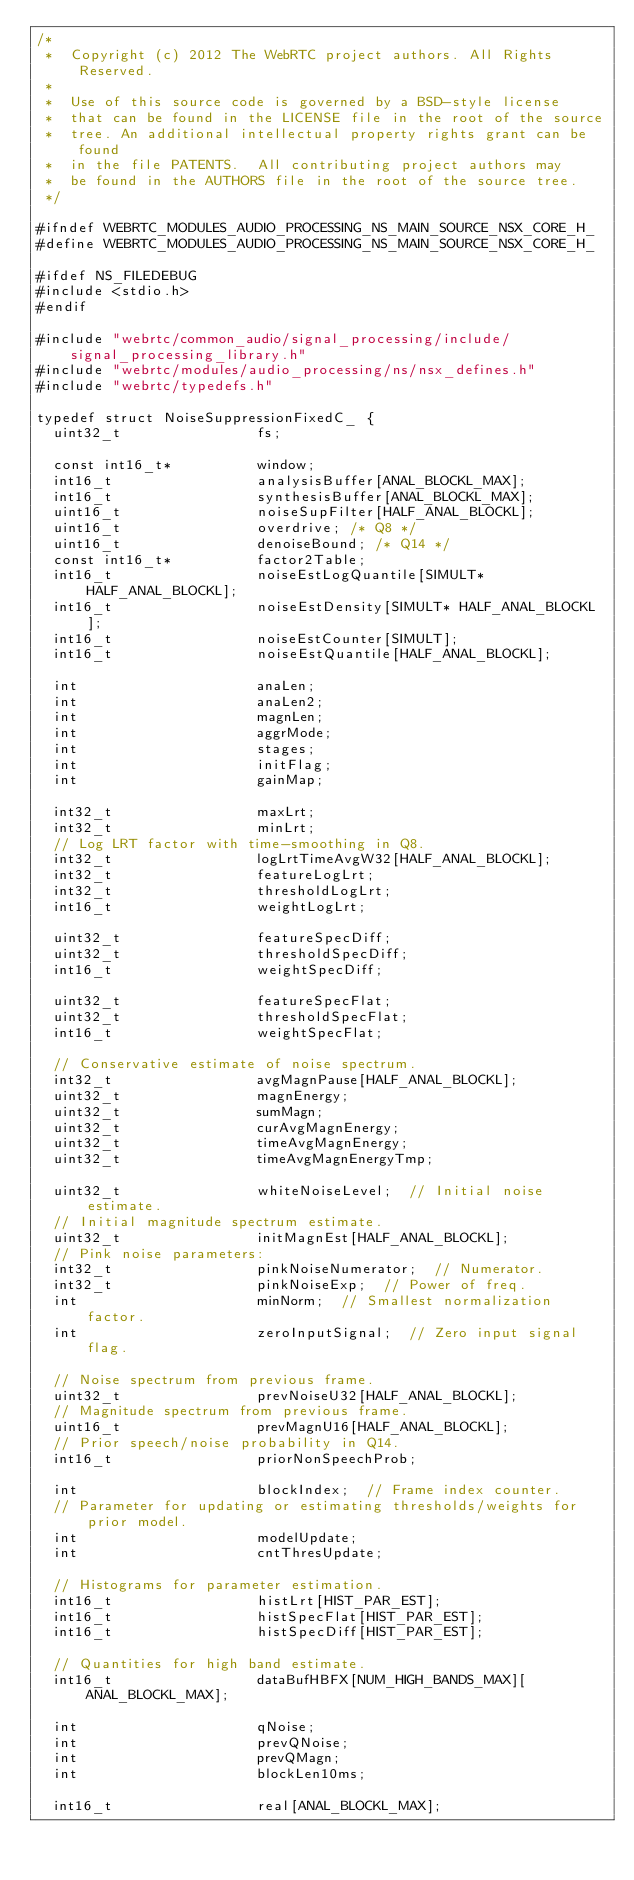Convert code to text. <code><loc_0><loc_0><loc_500><loc_500><_C_>/*
 *  Copyright (c) 2012 The WebRTC project authors. All Rights Reserved.
 *
 *  Use of this source code is governed by a BSD-style license
 *  that can be found in the LICENSE file in the root of the source
 *  tree. An additional intellectual property rights grant can be found
 *  in the file PATENTS.  All contributing project authors may
 *  be found in the AUTHORS file in the root of the source tree.
 */

#ifndef WEBRTC_MODULES_AUDIO_PROCESSING_NS_MAIN_SOURCE_NSX_CORE_H_
#define WEBRTC_MODULES_AUDIO_PROCESSING_NS_MAIN_SOURCE_NSX_CORE_H_

#ifdef NS_FILEDEBUG
#include <stdio.h>
#endif

#include "webrtc/common_audio/signal_processing/include/signal_processing_library.h"
#include "webrtc/modules/audio_processing/ns/nsx_defines.h"
#include "webrtc/typedefs.h"

typedef struct NoiseSuppressionFixedC_ {
  uint32_t                fs;

  const int16_t*          window;
  int16_t                 analysisBuffer[ANAL_BLOCKL_MAX];
  int16_t                 synthesisBuffer[ANAL_BLOCKL_MAX];
  uint16_t                noiseSupFilter[HALF_ANAL_BLOCKL];
  uint16_t                overdrive; /* Q8 */
  uint16_t                denoiseBound; /* Q14 */
  const int16_t*          factor2Table;
  int16_t                 noiseEstLogQuantile[SIMULT* HALF_ANAL_BLOCKL];
  int16_t                 noiseEstDensity[SIMULT* HALF_ANAL_BLOCKL];
  int16_t                 noiseEstCounter[SIMULT];
  int16_t                 noiseEstQuantile[HALF_ANAL_BLOCKL];

  int                     anaLen;
  int                     anaLen2;
  int                     magnLen;
  int                     aggrMode;
  int                     stages;
  int                     initFlag;
  int                     gainMap;

  int32_t                 maxLrt;
  int32_t                 minLrt;
  // Log LRT factor with time-smoothing in Q8.
  int32_t                 logLrtTimeAvgW32[HALF_ANAL_BLOCKL];
  int32_t                 featureLogLrt;
  int32_t                 thresholdLogLrt;
  int16_t                 weightLogLrt;

  uint32_t                featureSpecDiff;
  uint32_t                thresholdSpecDiff;
  int16_t                 weightSpecDiff;

  uint32_t                featureSpecFlat;
  uint32_t                thresholdSpecFlat;
  int16_t                 weightSpecFlat;

  // Conservative estimate of noise spectrum.
  int32_t                 avgMagnPause[HALF_ANAL_BLOCKL];
  uint32_t                magnEnergy;
  uint32_t                sumMagn;
  uint32_t                curAvgMagnEnergy;
  uint32_t                timeAvgMagnEnergy;
  uint32_t                timeAvgMagnEnergyTmp;

  uint32_t                whiteNoiseLevel;  // Initial noise estimate.
  // Initial magnitude spectrum estimate.
  uint32_t                initMagnEst[HALF_ANAL_BLOCKL];
  // Pink noise parameters:
  int32_t                 pinkNoiseNumerator;  // Numerator.
  int32_t                 pinkNoiseExp;  // Power of freq.
  int                     minNorm;  // Smallest normalization factor.
  int                     zeroInputSignal;  // Zero input signal flag.

  // Noise spectrum from previous frame.
  uint32_t                prevNoiseU32[HALF_ANAL_BLOCKL];
  // Magnitude spectrum from previous frame.
  uint16_t                prevMagnU16[HALF_ANAL_BLOCKL];
  // Prior speech/noise probability in Q14.
  int16_t                 priorNonSpeechProb;

  int                     blockIndex;  // Frame index counter.
  // Parameter for updating or estimating thresholds/weights for prior model.
  int                     modelUpdate;
  int                     cntThresUpdate;

  // Histograms for parameter estimation.
  int16_t                 histLrt[HIST_PAR_EST];
  int16_t                 histSpecFlat[HIST_PAR_EST];
  int16_t                 histSpecDiff[HIST_PAR_EST];

  // Quantities for high band estimate.
  int16_t                 dataBufHBFX[NUM_HIGH_BANDS_MAX][ANAL_BLOCKL_MAX];

  int                     qNoise;
  int                     prevQNoise;
  int                     prevQMagn;
  int                     blockLen10ms;

  int16_t                 real[ANAL_BLOCKL_MAX];</code> 